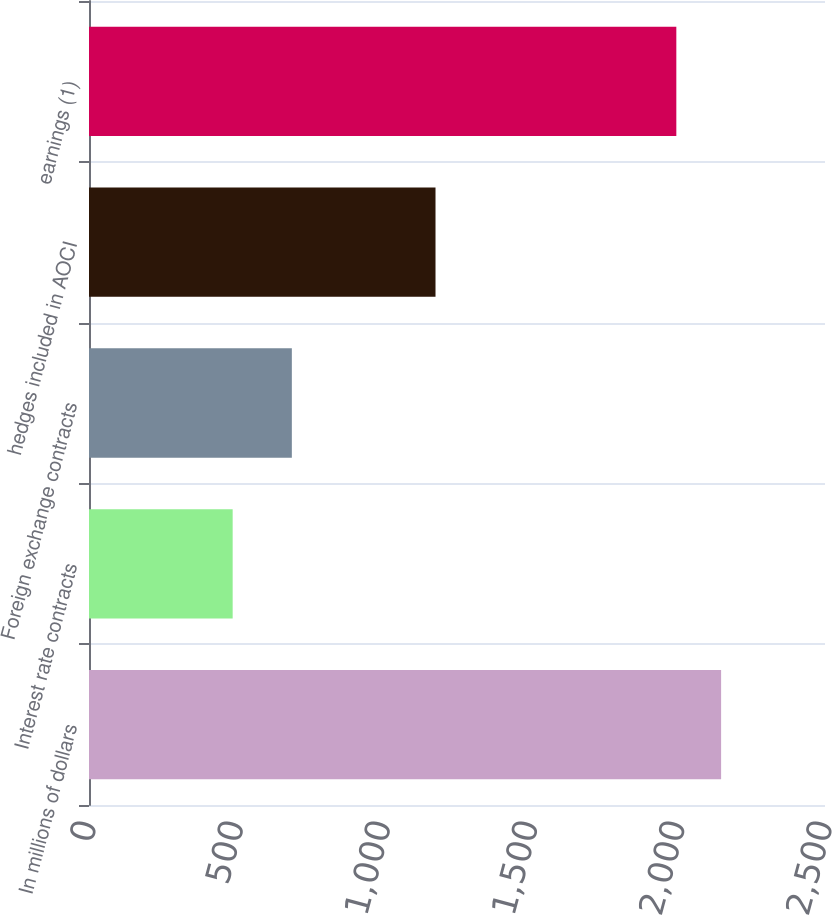Convert chart to OTSL. <chart><loc_0><loc_0><loc_500><loc_500><bar_chart><fcel>In millions of dollars<fcel>Interest rate contracts<fcel>Foreign exchange contracts<fcel>hedges included in AOCI<fcel>earnings (1)<nl><fcel>2147.1<fcel>488<fcel>689<fcel>1177<fcel>1995<nl></chart> 